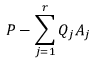Convert formula to latex. <formula><loc_0><loc_0><loc_500><loc_500>P - \sum _ { j = 1 } ^ { r } Q _ { j } A _ { j }</formula> 